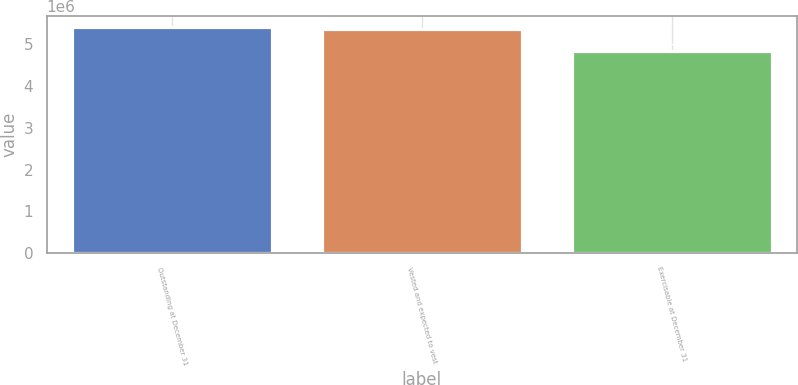Convert chart. <chart><loc_0><loc_0><loc_500><loc_500><bar_chart><fcel>Outstanding at December 31<fcel>Vested and expected to vest<fcel>Exercisable at December 31<nl><fcel>5.4188e+06<fcel>5.36507e+06<fcel>4.85326e+06<nl></chart> 